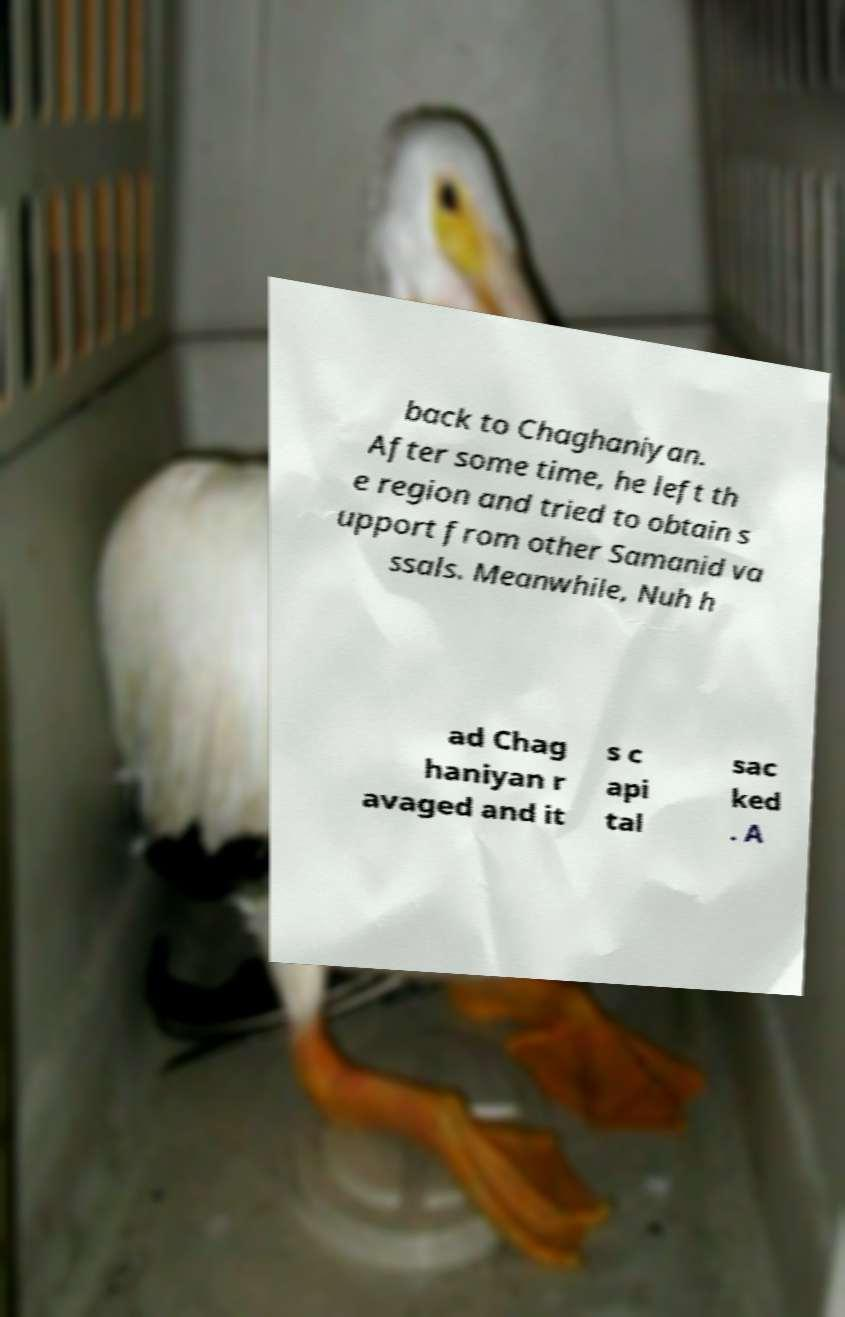Please identify and transcribe the text found in this image. back to Chaghaniyan. After some time, he left th e region and tried to obtain s upport from other Samanid va ssals. Meanwhile, Nuh h ad Chag haniyan r avaged and it s c api tal sac ked . A 